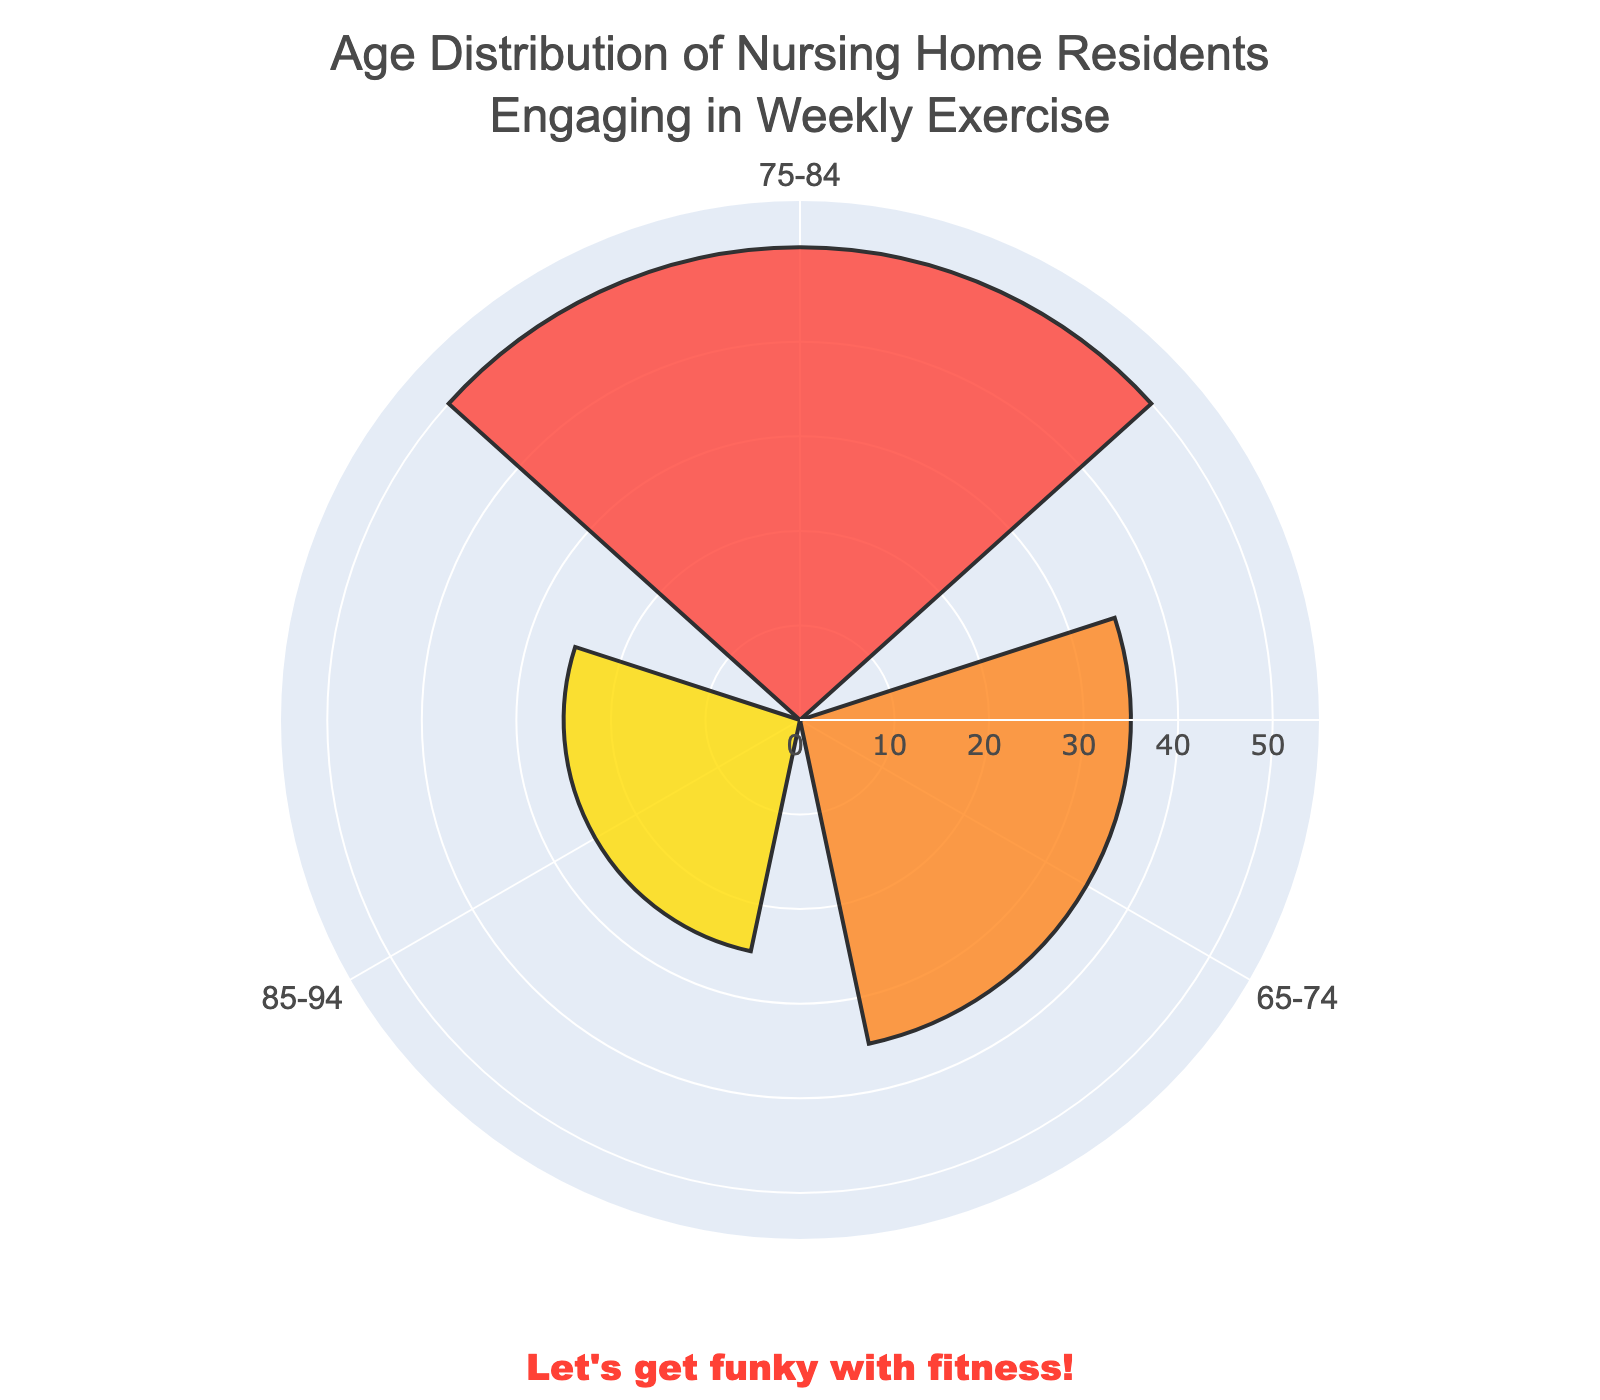How many age groups are represented in the plot? There are three age groups represented in the plot: 65-74, 75-84, and 85-94. The "95+" group is not included as only the top three groups are shown.
Answer: 3 Which age group has the highest number of participants engaging in weekly exercise? The plot shows the highest bar corresponds to the age group 75-84, indicating it as the group with the highest number of participants engaging in weekly exercise.
Answer: 75-84 What is the combined number of participants engaging in weekly exercise for the age groups 65-74 and 85-94? The plot shows 35 participants for the 65-74 group and 25 participants for the 85-94 group. Summing these gives 35 + 25 = 60.
Answer: 60 Between which two age groups is the difference in participants the smallest? The plot shows the smallest difference in participants is between the age groups 65-74 (35 participants) and 85-94 (25 participants), a difference of 10 participants.
Answer: 65-74 and 85-94 What percentage of the participants engaging in weekly exercise are from the 75-84 age group out of the three groups shown? Summing the participants in the top three groups: 35 (65-74) + 50 (75-84) + 25 (85-94) = 110. The percentage for the 75-84 group is (50 / 110) * 100% = 45.45%.
Answer: 45.45% Describe the color coding used in the plot to represent the age groups. The plot uses distinct colors to represent each age group: red for 65-74, orange for 75-84, and yellow for 85-94.
Answer: Red, orange, and yellow Which age group shows the least engagement in weekly exercise among those displayed? The age group with the lowest bar in the plot is 85-94, showing the least engagement in weekly exercise among the top three groups.
Answer: 85-94 How many more participants are in the 75-84 group compared to the 65-74 group? The plot shows 50 participants in the 75-84 group and 35 in the 65-74 group. The difference is 50 - 35 = 15.
Answer: 15 Is the number of participants engaging in weekly exercise decreasing or increasing with age among the groups shown? By examining the bars, we can see that the number of participants increases from the 65-74 group to the 75-84 group, and then decreases for the 85-94 group.
Answer: Increases before decreasing What funky annotation is included in the plot? At the bottom of the plot, there is an annotation that reads, "Let's get funky with fitness!"
Answer: “Let's get funky with fitness!” 